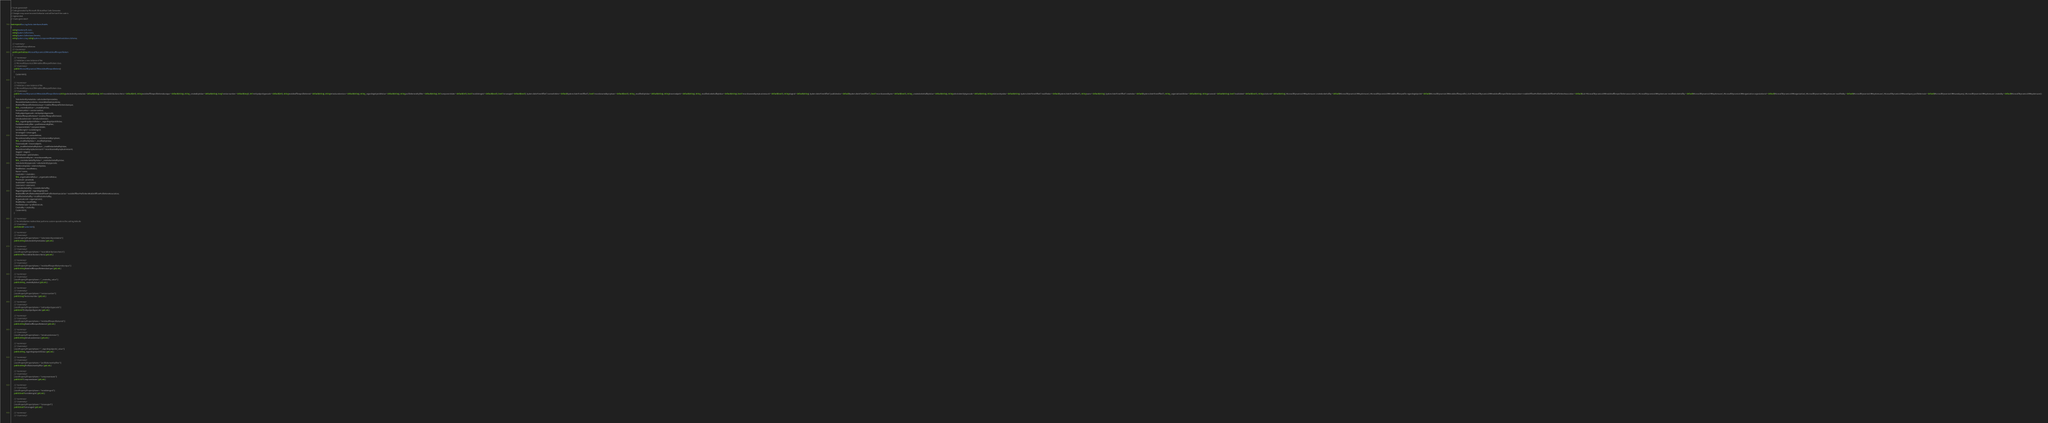Convert code to text. <code><loc_0><loc_0><loc_500><loc_500><_C#_>// <auto-generated>
// Code generated by Microsoft (R) AutoRest Code Generator.
// Changes may cause incorrect behavior and will be lost if the code is
// regenerated.
// </auto-generated>

namespace Gov.Jag.Embc.Interfaces.Models
{
    using Newtonsoft.Json;
    using System.Collections;
    using System.Collections.Generic;
    using System.Linq; using System.ComponentModel.DataAnnotations.Schema;

    /// <summary>
    /// mobileofflineprofileitem
    /// </summary>
    public partial class MicrosoftDynamicsCRMmobileofflineprofileitem
    {
        /// <summary>
        /// Initializes a new instance of the
        /// MicrosoftDynamicsCRMmobileofflineprofileitem class.
        /// </summary>
        public MicrosoftDynamicsCRMmobileofflineprofileitem()
        {
            CustomInit();
        }

        /// <summary>
        /// Initializes a new instance of the
        /// MicrosoftDynamicsCRMmobileofflineprofileitem class.
        /// </summary>
        public MicrosoftDynamicsCRMmobileofflineprofileitem(string selectedentitymetadata = default(string), int? recorddistributioncriteria = default(int?), string mobileofflineprofileitemidunique = default(string), string _createdbyValue = default(string), long? versionnumber = default(long?), int? entityobjecttypecode = default(int?), string mobileofflineprofileitemid = default(string), string introducedversion = default(string), string _regardingobjectidValue = default(string), string profileitementityfilter = default(string), int? componentstate = default(int?), bool? isvisibleingrid = default(bool?), bool? ismanaged = default(bool?), System.DateTimeOffset? overwritetime = default(System.DateTimeOffset?), bool? recordsownedbymyteam = default(bool?), string _modifiedbyValue = default(string), string traversedpath = default(string), string _modifiedonbehalfbyValue = default(string), bool? recordsownedbymybusinessunit = default(bool?), string stageid = default(string), System.DateTimeOffset? publishedon = default(System.DateTimeOffset?), bool? recordsownedbyme = default(bool?), string _createdonbehalfbyValue = default(string), string selectedentitytypecode = default(string), string relationshipdata = default(string), System.DateTimeOffset? modifiedon = default(System.DateTimeOffset?), string name = default(string), System.DateTimeOffset? createdon = default(System.DateTimeOffset?), string _organizationidValue = default(string), string processid = default(string), bool? isvalidated = default(bool?), string solutionid = default(string), MicrosoftDynamicsCRMsystemuser createdonbehalfby = default(MicrosoftDynamicsCRMsystemuser), MicrosoftDynamicsCRMmobileofflineprofile regardingobjectid = default(MicrosoftDynamicsCRMmobileofflineprofile), IList<MicrosoftDynamicsCRMmobileofflineprofileitemassociation> mobileOfflineProfileItemMobileOfflineProfileItemAssociation = default(IList<MicrosoftDynamicsCRMmobileofflineprofileitemassociation>), MicrosoftDynamicsCRMsystemuser modifiedonbehalfby = default(MicrosoftDynamicsCRMsystemuser), MicrosoftDynamicsCRMorganization organizationid = default(MicrosoftDynamicsCRMorganization), MicrosoftDynamicsCRMsystemuser modifiedby = default(MicrosoftDynamicsCRMsystemuser), MicrosoftDynamicsCRMsavedquery profileitemrule = default(MicrosoftDynamicsCRMsavedquery), MicrosoftDynamicsCRMsystemuser createdby = default(MicrosoftDynamicsCRMsystemuser))
        {
            Selectedentitymetadata = selectedentitymetadata;
            Recorddistributioncriteria = recorddistributioncriteria;
            Mobileofflineprofileitemidunique = mobileofflineprofileitemidunique;
            this._createdbyValue = _createdbyValue;
            Versionnumber = versionnumber;
            Entityobjecttypecode = entityobjecttypecode;
            Mobileofflineprofileitemid = mobileofflineprofileitemid;
            Introducedversion = introducedversion;
            this._regardingobjectidValue = _regardingobjectidValue;
            Profileitementityfilter = profileitementityfilter;
            Componentstate = componentstate;
            Isvisibleingrid = isvisibleingrid;
            Ismanaged = ismanaged;
            Overwritetime = overwritetime;
            Recordsownedbymyteam = recordsownedbymyteam;
            this._modifiedbyValue = _modifiedbyValue;
            Traversedpath = traversedpath;
            this._modifiedonbehalfbyValue = _modifiedonbehalfbyValue;
            Recordsownedbymybusinessunit = recordsownedbymybusinessunit;
            Stageid = stageid;
            Publishedon = publishedon;
            Recordsownedbyme = recordsownedbyme;
            this._createdonbehalfbyValue = _createdonbehalfbyValue;
            Selectedentitytypecode = selectedentitytypecode;
            Relationshipdata = relationshipdata;
            Modifiedon = modifiedon;
            Name = name;
            Createdon = createdon;
            this._organizationidValue = _organizationidValue;
            Processid = processid;
            Isvalidated = isvalidated;
            Solutionid = solutionid;
            Createdonbehalfby = createdonbehalfby;
            Regardingobjectid = regardingobjectid;
            MobileOfflineProfileItemMobileOfflineProfileItemAssociation = mobileOfflineProfileItemMobileOfflineProfileItemAssociation;
            Modifiedonbehalfby = modifiedonbehalfby;
            Organizationid = organizationid;
            Modifiedby = modifiedby;
            Profileitemrule = profileitemrule;
            Createdby = createdby;
            CustomInit();
        }

        /// <summary>
        /// An initialization method that performs custom operations like setting defaults
        /// </summary>
        partial void CustomInit();

        /// <summary>
        /// </summary>
        [JsonProperty(PropertyName = "selectedentitymetadata")]
        public string Selectedentitymetadata { get; set; }

        /// <summary>
        /// </summary>
        [JsonProperty(PropertyName = "recorddistributioncriteria")]
        public int? Recorddistributioncriteria { get; set; }

        /// <summary>
        /// </summary>
        [JsonProperty(PropertyName = "mobileofflineprofileitemidunique")]
        public string Mobileofflineprofileitemidunique { get; set; }

        /// <summary>
        /// </summary>
        [JsonProperty(PropertyName = "_createdby_value")]
        public string _createdbyValue { get; set; }

        /// <summary>
        /// </summary>
        [JsonProperty(PropertyName = "versionnumber")]
        public long? Versionnumber { get; set; }

        /// <summary>
        /// </summary>
        [JsonProperty(PropertyName = "entityobjecttypecode")]
        public int? Entityobjecttypecode { get; set; }

        /// <summary>
        /// </summary>
        [JsonProperty(PropertyName = "mobileofflineprofileitemid")]
        public string Mobileofflineprofileitemid { get; set; }

        /// <summary>
        /// </summary>
        [JsonProperty(PropertyName = "introducedversion")]
        public string Introducedversion { get; set; }

        /// <summary>
        /// </summary>
        [JsonProperty(PropertyName = "_regardingobjectid_value")]
        public string _regardingobjectidValue { get; set; }

        /// <summary>
        /// </summary>
        [JsonProperty(PropertyName = "profileitementityfilter")]
        public string Profileitementityfilter { get; set; }

        /// <summary>
        /// </summary>
        [JsonProperty(PropertyName = "componentstate")]
        public int? Componentstate { get; set; }

        /// <summary>
        /// </summary>
        [JsonProperty(PropertyName = "isvisibleingrid")]
        public bool? Isvisibleingrid { get; set; }

        /// <summary>
        /// </summary>
        [JsonProperty(PropertyName = "ismanaged")]
        public bool? Ismanaged { get; set; }

        /// <summary>
        /// </summary></code> 